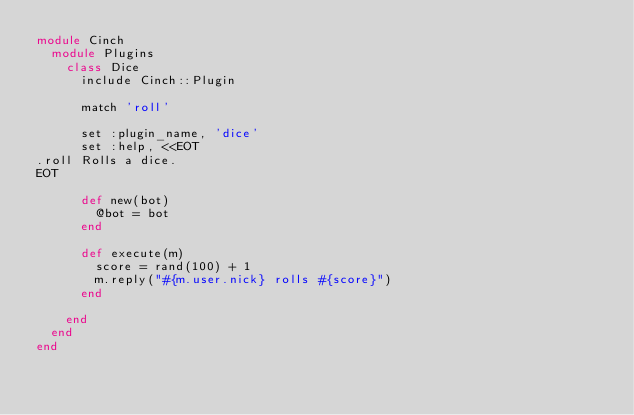Convert code to text. <code><loc_0><loc_0><loc_500><loc_500><_Ruby_>module Cinch
  module Plugins
    class Dice
      include Cinch::Plugin

      match 'roll'

      set :plugin_name, 'dice'
      set :help, <<EOT
.roll Rolls a dice.
EOT

      def new(bot)
        @bot = bot
      end

      def execute(m)
        score = rand(100) + 1
        m.reply("#{m.user.nick} rolls #{score}")
      end

    end
  end
end
</code> 